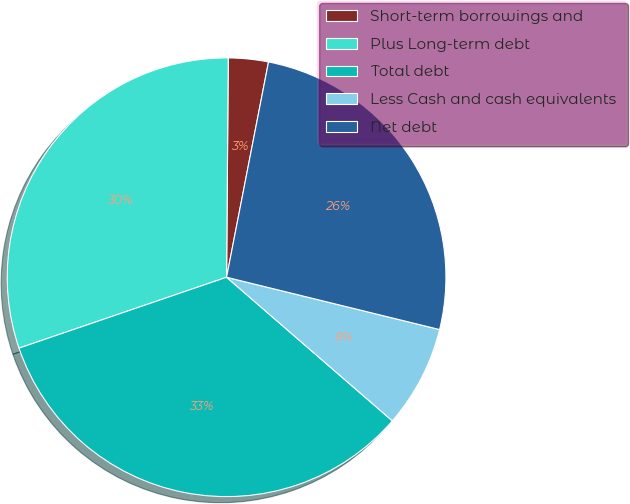<chart> <loc_0><loc_0><loc_500><loc_500><pie_chart><fcel>Short-term borrowings and<fcel>Plus Long-term debt<fcel>Total debt<fcel>Less Cash and cash equivalents<fcel>Net debt<nl><fcel>2.94%<fcel>30.36%<fcel>33.4%<fcel>7.53%<fcel>25.77%<nl></chart> 